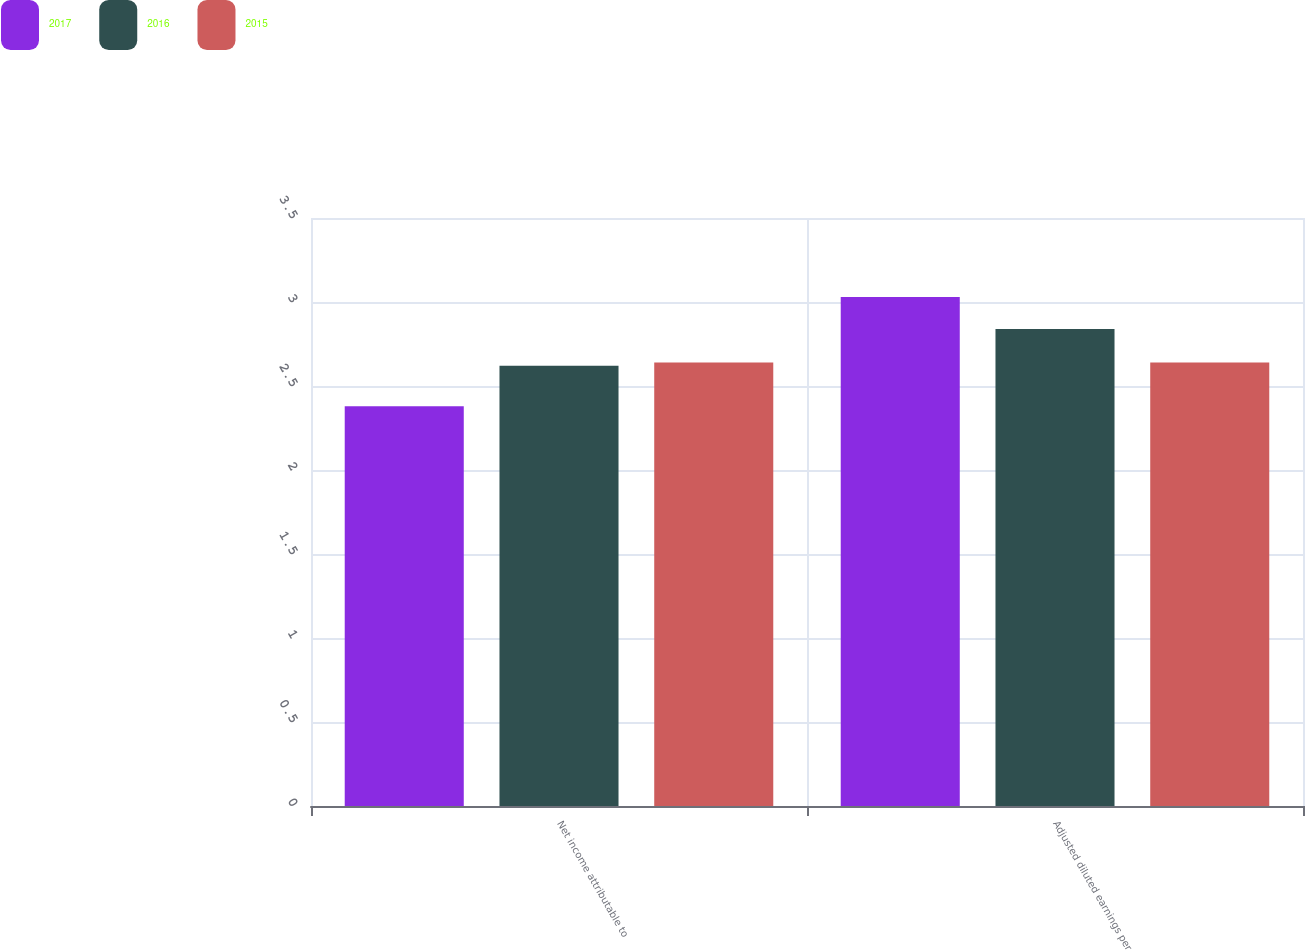<chart> <loc_0><loc_0><loc_500><loc_500><stacked_bar_chart><ecel><fcel>Net income attributable to<fcel>Adjusted diluted earnings per<nl><fcel>2017<fcel>2.38<fcel>3.03<nl><fcel>2016<fcel>2.62<fcel>2.84<nl><fcel>2015<fcel>2.64<fcel>2.64<nl></chart> 